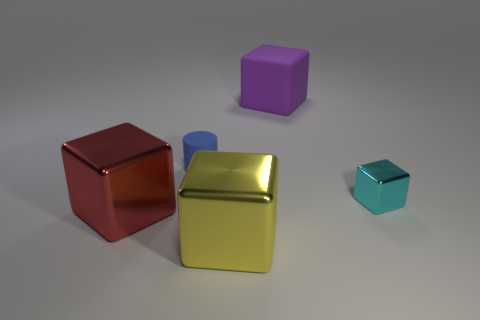Subtract 1 blocks. How many blocks are left? 3 Add 4 metal things. How many objects exist? 9 Subtract all green blocks. Subtract all brown spheres. How many blocks are left? 4 Subtract all cubes. How many objects are left? 1 Add 5 small cyan shiny blocks. How many small cyan shiny blocks exist? 6 Subtract 0 red cylinders. How many objects are left? 5 Subtract all large yellow metallic objects. Subtract all large yellow metallic things. How many objects are left? 3 Add 4 tiny blue cylinders. How many tiny blue cylinders are left? 5 